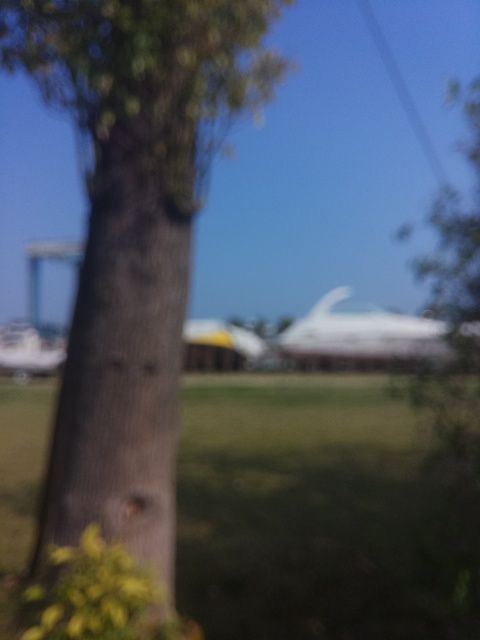Can you describe the setting of this image? The setting appears to be an outdoor location with greenery. A tree is prominent in the foreground, and there seems to be a blurred structure in the background, which could suggest a park with buildings in the distance. 